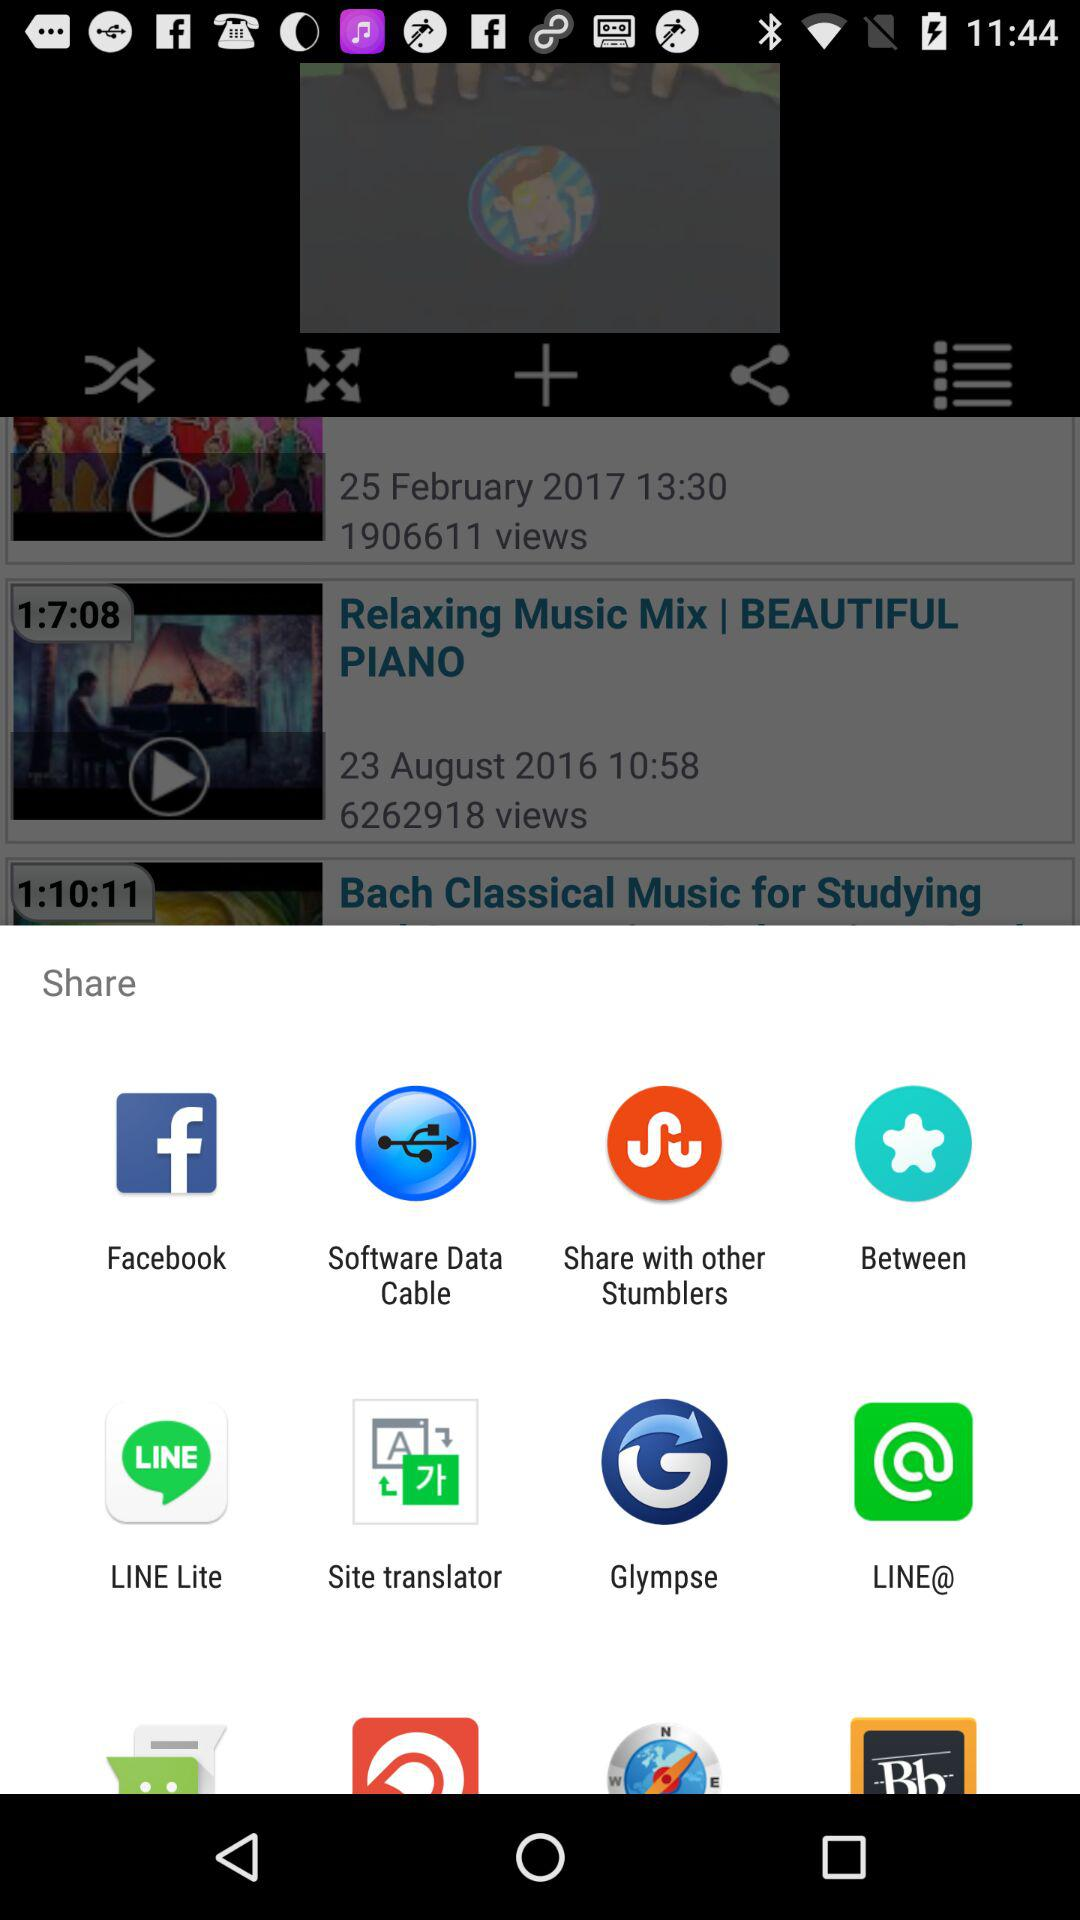Who posted "Relaxing Music Mix | BEAUTIFUL PIANO"?
When the provided information is insufficient, respond with <no answer>. <no answer> 